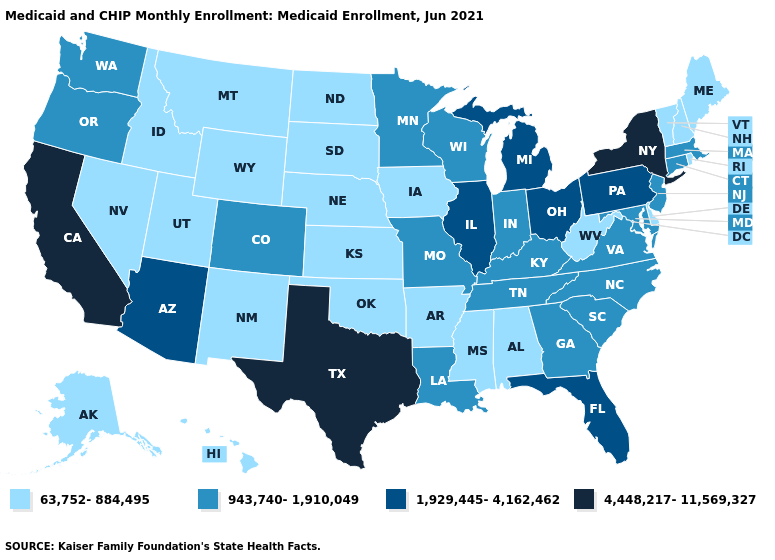What is the lowest value in the USA?
Keep it brief. 63,752-884,495. What is the value of Georgia?
Quick response, please. 943,740-1,910,049. What is the lowest value in the Northeast?
Concise answer only. 63,752-884,495. Among the states that border Wisconsin , does Iowa have the highest value?
Quick response, please. No. How many symbols are there in the legend?
Be succinct. 4. What is the value of Arizona?
Quick response, please. 1,929,445-4,162,462. Which states hav the highest value in the MidWest?
Quick response, please. Illinois, Michigan, Ohio. What is the highest value in the Northeast ?
Keep it brief. 4,448,217-11,569,327. Name the states that have a value in the range 63,752-884,495?
Concise answer only. Alabama, Alaska, Arkansas, Delaware, Hawaii, Idaho, Iowa, Kansas, Maine, Mississippi, Montana, Nebraska, Nevada, New Hampshire, New Mexico, North Dakota, Oklahoma, Rhode Island, South Dakota, Utah, Vermont, West Virginia, Wyoming. What is the lowest value in states that border Georgia?
Be succinct. 63,752-884,495. What is the value of Georgia?
Write a very short answer. 943,740-1,910,049. What is the value of Hawaii?
Quick response, please. 63,752-884,495. What is the highest value in states that border Alabama?
Give a very brief answer. 1,929,445-4,162,462. Which states have the highest value in the USA?
Be succinct. California, New York, Texas. Does the first symbol in the legend represent the smallest category?
Concise answer only. Yes. 